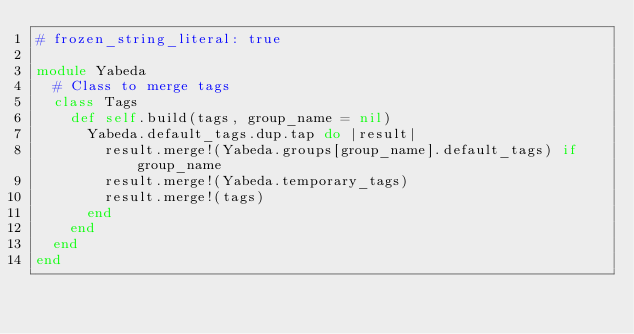<code> <loc_0><loc_0><loc_500><loc_500><_Ruby_># frozen_string_literal: true

module Yabeda
  # Class to merge tags
  class Tags
    def self.build(tags, group_name = nil)
      Yabeda.default_tags.dup.tap do |result|
        result.merge!(Yabeda.groups[group_name].default_tags) if group_name
        result.merge!(Yabeda.temporary_tags)
        result.merge!(tags)
      end
    end
  end
end
</code> 